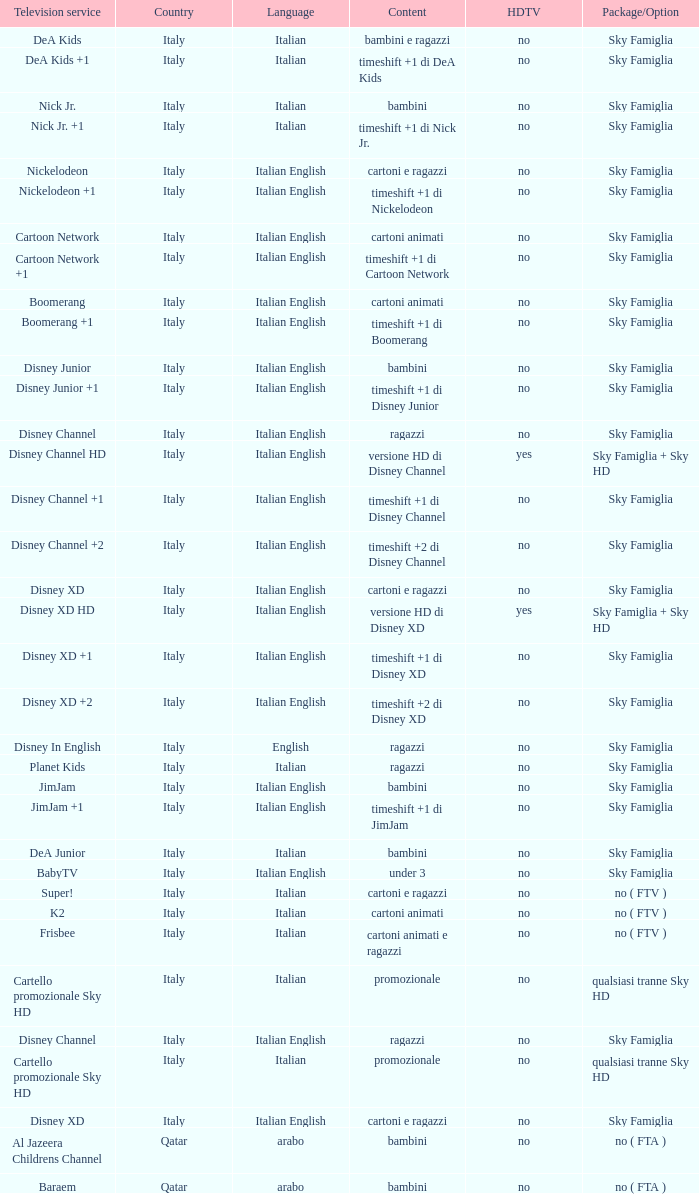What is the nation where italian and english are spoken, and disney xd +1 is available as a tv service? Italy. 